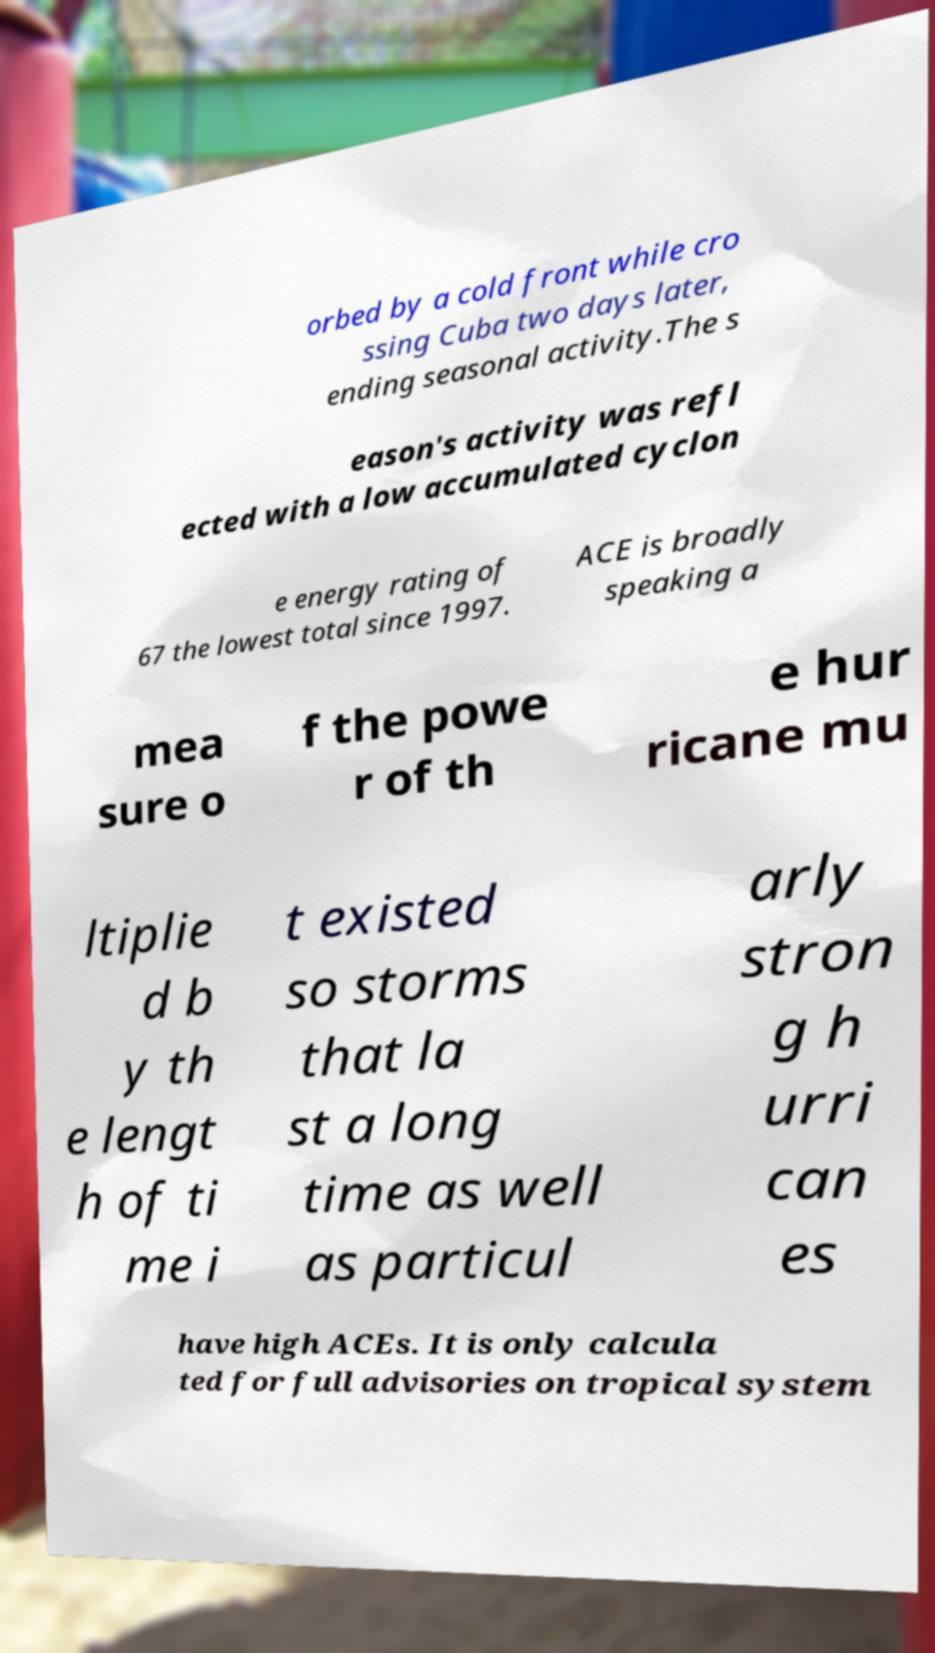Please read and relay the text visible in this image. What does it say? orbed by a cold front while cro ssing Cuba two days later, ending seasonal activity.The s eason's activity was refl ected with a low accumulated cyclon e energy rating of 67 the lowest total since 1997. ACE is broadly speaking a mea sure o f the powe r of th e hur ricane mu ltiplie d b y th e lengt h of ti me i t existed so storms that la st a long time as well as particul arly stron g h urri can es have high ACEs. It is only calcula ted for full advisories on tropical system 